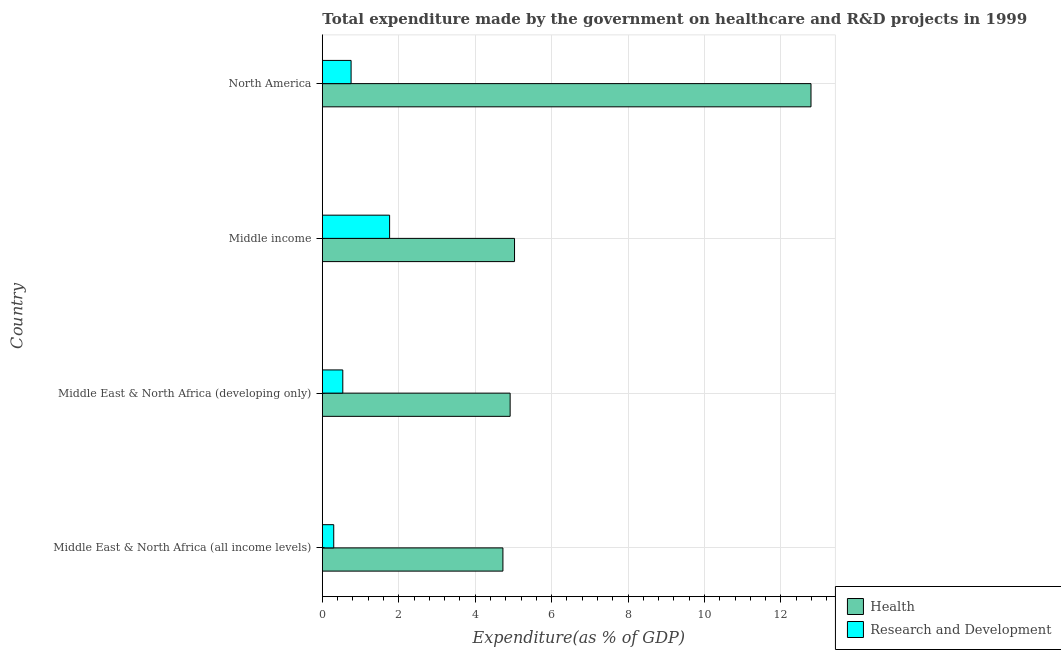How many different coloured bars are there?
Make the answer very short. 2. How many groups of bars are there?
Keep it short and to the point. 4. Are the number of bars on each tick of the Y-axis equal?
Provide a short and direct response. Yes. How many bars are there on the 2nd tick from the bottom?
Offer a terse response. 2. What is the label of the 3rd group of bars from the top?
Your response must be concise. Middle East & North Africa (developing only). In how many cases, is the number of bars for a given country not equal to the number of legend labels?
Your answer should be very brief. 0. What is the expenditure in r&d in Middle East & North Africa (all income levels)?
Your answer should be very brief. 0.3. Across all countries, what is the maximum expenditure in healthcare?
Offer a very short reply. 12.79. Across all countries, what is the minimum expenditure in r&d?
Ensure brevity in your answer.  0.3. In which country was the expenditure in r&d minimum?
Offer a terse response. Middle East & North Africa (all income levels). What is the total expenditure in r&d in the graph?
Give a very brief answer. 3.35. What is the difference between the expenditure in r&d in Middle East & North Africa (all income levels) and that in Middle income?
Your answer should be very brief. -1.46. What is the difference between the expenditure in healthcare in Middle income and the expenditure in r&d in Middle East & North Africa (developing only)?
Provide a short and direct response. 4.49. What is the average expenditure in healthcare per country?
Your answer should be compact. 6.86. What is the difference between the expenditure in r&d and expenditure in healthcare in North America?
Your response must be concise. -12.03. What is the ratio of the expenditure in healthcare in Middle East & North Africa (developing only) to that in North America?
Ensure brevity in your answer.  0.38. What is the difference between the highest and the second highest expenditure in healthcare?
Keep it short and to the point. 7.76. What is the difference between the highest and the lowest expenditure in healthcare?
Your answer should be very brief. 8.06. In how many countries, is the expenditure in healthcare greater than the average expenditure in healthcare taken over all countries?
Your answer should be compact. 1. Is the sum of the expenditure in r&d in Middle East & North Africa (developing only) and Middle income greater than the maximum expenditure in healthcare across all countries?
Keep it short and to the point. No. What does the 1st bar from the top in Middle East & North Africa (developing only) represents?
Give a very brief answer. Research and Development. What does the 2nd bar from the bottom in Middle East & North Africa (all income levels) represents?
Make the answer very short. Research and Development. How many bars are there?
Your response must be concise. 8. How many countries are there in the graph?
Your answer should be very brief. 4. What is the difference between two consecutive major ticks on the X-axis?
Give a very brief answer. 2. Are the values on the major ticks of X-axis written in scientific E-notation?
Make the answer very short. No. Does the graph contain grids?
Your answer should be compact. Yes. How many legend labels are there?
Ensure brevity in your answer.  2. What is the title of the graph?
Your answer should be compact. Total expenditure made by the government on healthcare and R&D projects in 1999. What is the label or title of the X-axis?
Your response must be concise. Expenditure(as % of GDP). What is the Expenditure(as % of GDP) of Health in Middle East & North Africa (all income levels)?
Make the answer very short. 4.73. What is the Expenditure(as % of GDP) in Research and Development in Middle East & North Africa (all income levels)?
Your response must be concise. 0.3. What is the Expenditure(as % of GDP) in Health in Middle East & North Africa (developing only)?
Your response must be concise. 4.91. What is the Expenditure(as % of GDP) of Research and Development in Middle East & North Africa (developing only)?
Offer a terse response. 0.54. What is the Expenditure(as % of GDP) in Health in Middle income?
Your answer should be compact. 5.03. What is the Expenditure(as % of GDP) of Research and Development in Middle income?
Provide a short and direct response. 1.76. What is the Expenditure(as % of GDP) of Health in North America?
Ensure brevity in your answer.  12.79. What is the Expenditure(as % of GDP) of Research and Development in North America?
Provide a succinct answer. 0.75. Across all countries, what is the maximum Expenditure(as % of GDP) in Health?
Offer a very short reply. 12.79. Across all countries, what is the maximum Expenditure(as % of GDP) in Research and Development?
Your answer should be compact. 1.76. Across all countries, what is the minimum Expenditure(as % of GDP) in Health?
Provide a short and direct response. 4.73. Across all countries, what is the minimum Expenditure(as % of GDP) in Research and Development?
Provide a short and direct response. 0.3. What is the total Expenditure(as % of GDP) in Health in the graph?
Keep it short and to the point. 27.46. What is the total Expenditure(as % of GDP) in Research and Development in the graph?
Provide a short and direct response. 3.35. What is the difference between the Expenditure(as % of GDP) of Health in Middle East & North Africa (all income levels) and that in Middle East & North Africa (developing only)?
Your answer should be compact. -0.19. What is the difference between the Expenditure(as % of GDP) of Research and Development in Middle East & North Africa (all income levels) and that in Middle East & North Africa (developing only)?
Provide a short and direct response. -0.24. What is the difference between the Expenditure(as % of GDP) in Health in Middle East & North Africa (all income levels) and that in Middle income?
Give a very brief answer. -0.3. What is the difference between the Expenditure(as % of GDP) in Research and Development in Middle East & North Africa (all income levels) and that in Middle income?
Offer a terse response. -1.46. What is the difference between the Expenditure(as % of GDP) in Health in Middle East & North Africa (all income levels) and that in North America?
Provide a succinct answer. -8.06. What is the difference between the Expenditure(as % of GDP) in Research and Development in Middle East & North Africa (all income levels) and that in North America?
Your response must be concise. -0.45. What is the difference between the Expenditure(as % of GDP) in Health in Middle East & North Africa (developing only) and that in Middle income?
Keep it short and to the point. -0.11. What is the difference between the Expenditure(as % of GDP) of Research and Development in Middle East & North Africa (developing only) and that in Middle income?
Give a very brief answer. -1.22. What is the difference between the Expenditure(as % of GDP) of Health in Middle East & North Africa (developing only) and that in North America?
Your response must be concise. -7.87. What is the difference between the Expenditure(as % of GDP) of Research and Development in Middle East & North Africa (developing only) and that in North America?
Your response must be concise. -0.22. What is the difference between the Expenditure(as % of GDP) of Health in Middle income and that in North America?
Your answer should be compact. -7.76. What is the difference between the Expenditure(as % of GDP) of Research and Development in Middle income and that in North America?
Provide a succinct answer. 1.01. What is the difference between the Expenditure(as % of GDP) in Health in Middle East & North Africa (all income levels) and the Expenditure(as % of GDP) in Research and Development in Middle East & North Africa (developing only)?
Offer a terse response. 4.19. What is the difference between the Expenditure(as % of GDP) of Health in Middle East & North Africa (all income levels) and the Expenditure(as % of GDP) of Research and Development in Middle income?
Provide a short and direct response. 2.97. What is the difference between the Expenditure(as % of GDP) in Health in Middle East & North Africa (all income levels) and the Expenditure(as % of GDP) in Research and Development in North America?
Provide a succinct answer. 3.97. What is the difference between the Expenditure(as % of GDP) of Health in Middle East & North Africa (developing only) and the Expenditure(as % of GDP) of Research and Development in Middle income?
Provide a short and direct response. 3.15. What is the difference between the Expenditure(as % of GDP) of Health in Middle East & North Africa (developing only) and the Expenditure(as % of GDP) of Research and Development in North America?
Offer a terse response. 4.16. What is the difference between the Expenditure(as % of GDP) in Health in Middle income and the Expenditure(as % of GDP) in Research and Development in North America?
Your answer should be very brief. 4.28. What is the average Expenditure(as % of GDP) of Health per country?
Offer a very short reply. 6.86. What is the average Expenditure(as % of GDP) of Research and Development per country?
Your answer should be very brief. 0.84. What is the difference between the Expenditure(as % of GDP) of Health and Expenditure(as % of GDP) of Research and Development in Middle East & North Africa (all income levels)?
Provide a succinct answer. 4.43. What is the difference between the Expenditure(as % of GDP) of Health and Expenditure(as % of GDP) of Research and Development in Middle East & North Africa (developing only)?
Provide a succinct answer. 4.38. What is the difference between the Expenditure(as % of GDP) in Health and Expenditure(as % of GDP) in Research and Development in Middle income?
Ensure brevity in your answer.  3.27. What is the difference between the Expenditure(as % of GDP) of Health and Expenditure(as % of GDP) of Research and Development in North America?
Ensure brevity in your answer.  12.03. What is the ratio of the Expenditure(as % of GDP) of Health in Middle East & North Africa (all income levels) to that in Middle East & North Africa (developing only)?
Offer a terse response. 0.96. What is the ratio of the Expenditure(as % of GDP) in Research and Development in Middle East & North Africa (all income levels) to that in Middle East & North Africa (developing only)?
Ensure brevity in your answer.  0.56. What is the ratio of the Expenditure(as % of GDP) in Health in Middle East & North Africa (all income levels) to that in Middle income?
Offer a very short reply. 0.94. What is the ratio of the Expenditure(as % of GDP) of Research and Development in Middle East & North Africa (all income levels) to that in Middle income?
Ensure brevity in your answer.  0.17. What is the ratio of the Expenditure(as % of GDP) in Health in Middle East & North Africa (all income levels) to that in North America?
Provide a succinct answer. 0.37. What is the ratio of the Expenditure(as % of GDP) in Research and Development in Middle East & North Africa (all income levels) to that in North America?
Provide a short and direct response. 0.4. What is the ratio of the Expenditure(as % of GDP) in Health in Middle East & North Africa (developing only) to that in Middle income?
Your response must be concise. 0.98. What is the ratio of the Expenditure(as % of GDP) of Research and Development in Middle East & North Africa (developing only) to that in Middle income?
Ensure brevity in your answer.  0.3. What is the ratio of the Expenditure(as % of GDP) in Health in Middle East & North Africa (developing only) to that in North America?
Ensure brevity in your answer.  0.38. What is the ratio of the Expenditure(as % of GDP) of Research and Development in Middle East & North Africa (developing only) to that in North America?
Give a very brief answer. 0.71. What is the ratio of the Expenditure(as % of GDP) of Health in Middle income to that in North America?
Provide a succinct answer. 0.39. What is the ratio of the Expenditure(as % of GDP) of Research and Development in Middle income to that in North America?
Ensure brevity in your answer.  2.34. What is the difference between the highest and the second highest Expenditure(as % of GDP) in Health?
Your answer should be compact. 7.76. What is the difference between the highest and the second highest Expenditure(as % of GDP) in Research and Development?
Ensure brevity in your answer.  1.01. What is the difference between the highest and the lowest Expenditure(as % of GDP) of Health?
Your answer should be very brief. 8.06. What is the difference between the highest and the lowest Expenditure(as % of GDP) of Research and Development?
Ensure brevity in your answer.  1.46. 